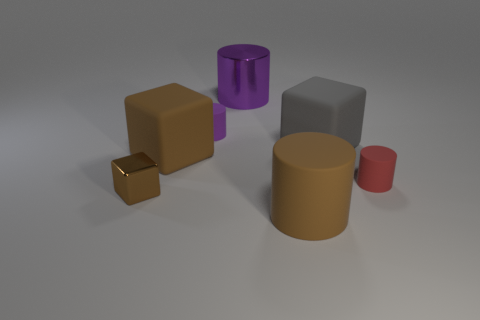What color is the block on the right side of the big thing that is in front of the large brown object that is behind the brown metal thing?
Give a very brief answer. Gray. Is the number of objects left of the tiny brown metallic thing less than the number of green rubber cylinders?
Offer a very short reply. No. There is a metallic object that is in front of the tiny red matte object; is it the same shape as the brown rubber object that is in front of the tiny brown metallic block?
Your response must be concise. No. What number of things are either large cylinders in front of the red matte cylinder or large rubber things?
Make the answer very short. 3. There is a cylinder that is the same color as the tiny metal object; what is it made of?
Keep it short and to the point. Rubber. Are there any matte blocks that are on the left side of the large cylinder behind the block to the right of the big brown cylinder?
Make the answer very short. Yes. Is the number of large purple shiny cylinders in front of the small cube less than the number of big matte things that are right of the purple matte cylinder?
Your answer should be compact. Yes. The cube that is the same material as the large purple thing is what color?
Offer a very short reply. Brown. What color is the large rubber thing in front of the large brown rubber thing that is behind the small brown metallic block?
Keep it short and to the point. Brown. Are there any big matte things that have the same color as the small metallic cube?
Provide a succinct answer. Yes. 